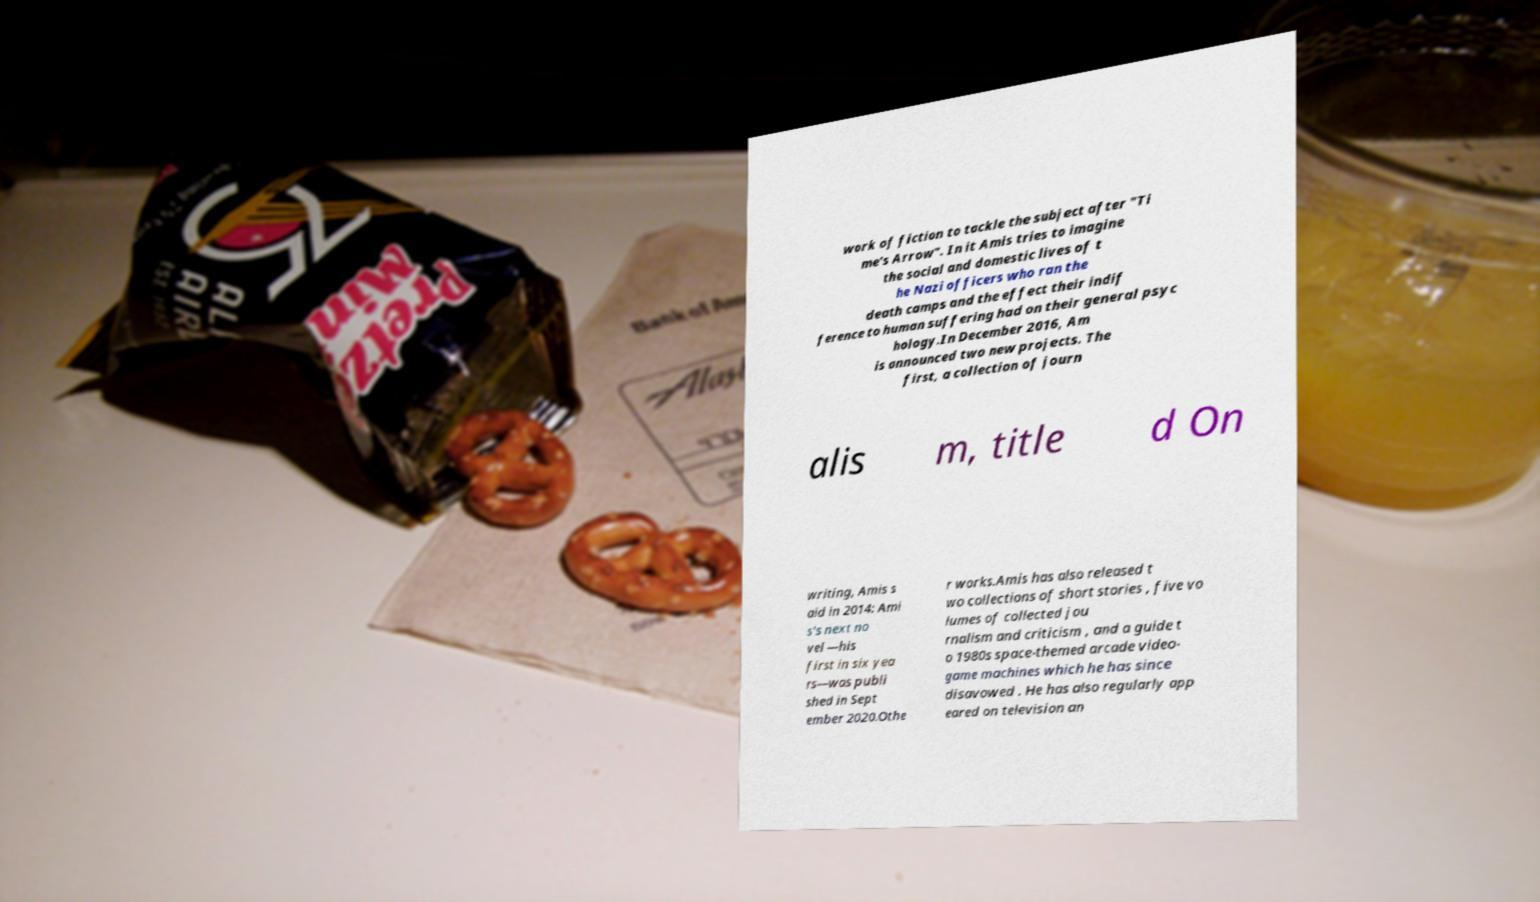Please identify and transcribe the text found in this image. work of fiction to tackle the subject after "Ti me's Arrow". In it Amis tries to imagine the social and domestic lives of t he Nazi officers who ran the death camps and the effect their indif ference to human suffering had on their general psyc hology.In December 2016, Am is announced two new projects. The first, a collection of journ alis m, title d On writing, Amis s aid in 2014: Ami s's next no vel —his first in six yea rs—was publi shed in Sept ember 2020.Othe r works.Amis has also released t wo collections of short stories , five vo lumes of collected jou rnalism and criticism , and a guide t o 1980s space-themed arcade video- game machines which he has since disavowed . He has also regularly app eared on television an 